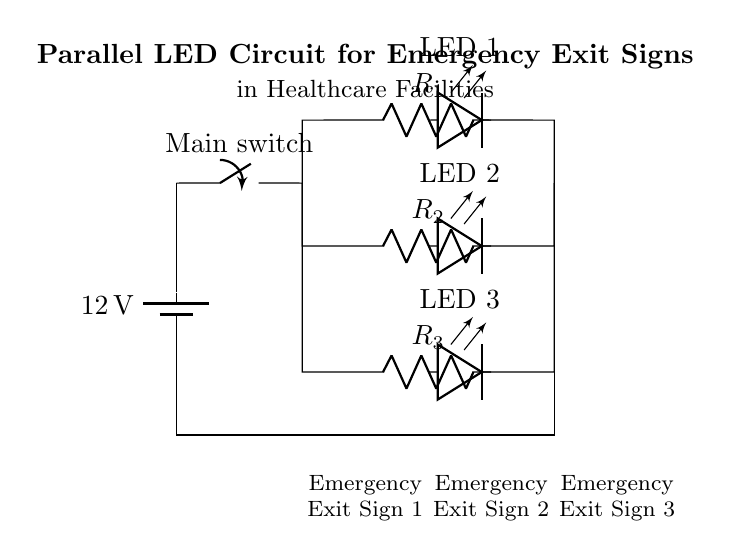What is the voltage of this circuit? The voltage is 12 volts, which is the value labeled on the battery, indicating the potential difference in the circuit.
Answer: 12 volts What type of circuit is this? This is a parallel circuit, as shown by the multiple branches connected directly to the same voltage source, allowing currents to diverge and each branch to operate independently.
Answer: Parallel How many LED indicators are present in this circuit? There are three LED indicators, as indicated by the three separate LED symbols drawn in the circuit diagram.
Answer: Three What is the function of the main switch? The main switch acts as a control mechanism to turn on or off the entire circuit, either allowing or interrupting the flow of current to all branches.
Answer: Control mechanism What happens to the other LEDs if one LED fails? The other LEDs will remain lit because in a parallel circuit, each branch operates independently; a failure in one branch does not affect the current in the others.
Answer: Remain lit What are the resistors labeled in this circuit? The resistors are labeled R1, R2, and R3, as shown in the diagram, each connected in parallel to the LEDs.
Answer: R1, R2, R3 Which component acts as a power source? The battery acts as the power source by providing the necessary voltage for the circuit, indicated at the start of the circuit diagram.
Answer: Battery 